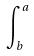Convert formula to latex. <formula><loc_0><loc_0><loc_500><loc_500>\int _ { b } ^ { a }</formula> 